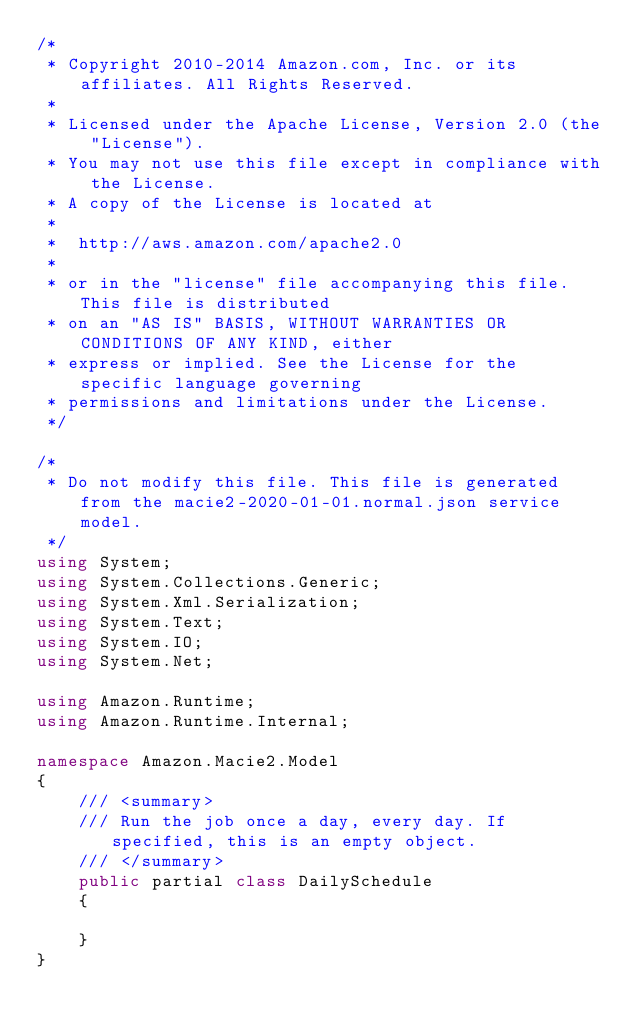<code> <loc_0><loc_0><loc_500><loc_500><_C#_>/*
 * Copyright 2010-2014 Amazon.com, Inc. or its affiliates. All Rights Reserved.
 * 
 * Licensed under the Apache License, Version 2.0 (the "License").
 * You may not use this file except in compliance with the License.
 * A copy of the License is located at
 * 
 *  http://aws.amazon.com/apache2.0
 * 
 * or in the "license" file accompanying this file. This file is distributed
 * on an "AS IS" BASIS, WITHOUT WARRANTIES OR CONDITIONS OF ANY KIND, either
 * express or implied. See the License for the specific language governing
 * permissions and limitations under the License.
 */

/*
 * Do not modify this file. This file is generated from the macie2-2020-01-01.normal.json service model.
 */
using System;
using System.Collections.Generic;
using System.Xml.Serialization;
using System.Text;
using System.IO;
using System.Net;

using Amazon.Runtime;
using Amazon.Runtime.Internal;

namespace Amazon.Macie2.Model
{
    /// <summary>
    /// Run the job once a day, every day. If specified, this is an empty object.
    /// </summary>
    public partial class DailySchedule
    {

    }
}</code> 